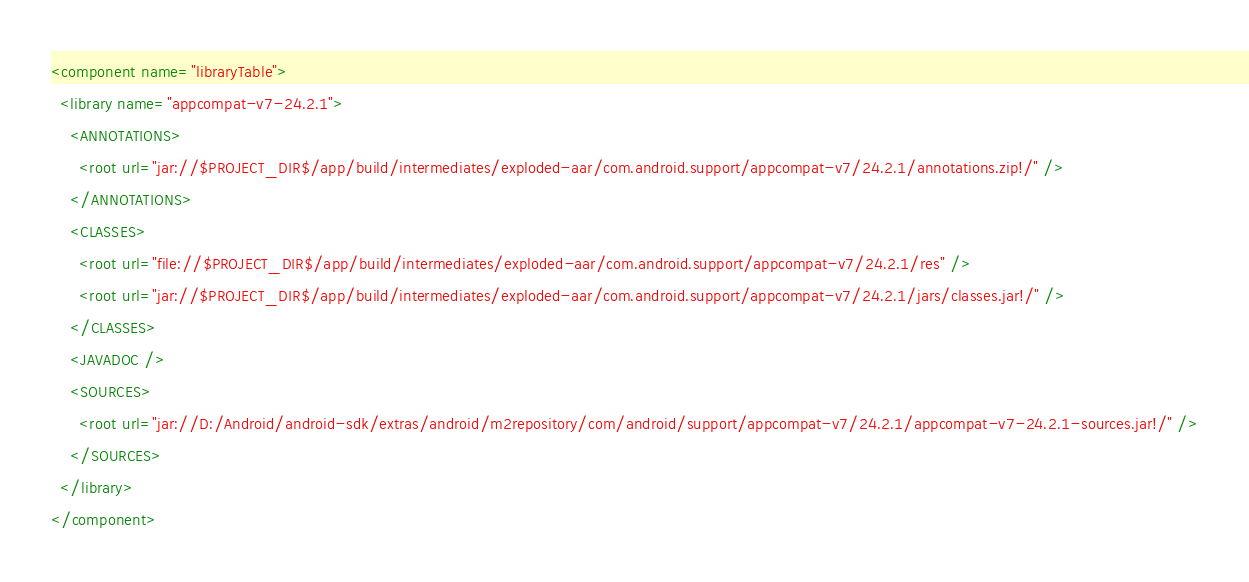Convert code to text. <code><loc_0><loc_0><loc_500><loc_500><_XML_><component name="libraryTable">
  <library name="appcompat-v7-24.2.1">
    <ANNOTATIONS>
      <root url="jar://$PROJECT_DIR$/app/build/intermediates/exploded-aar/com.android.support/appcompat-v7/24.2.1/annotations.zip!/" />
    </ANNOTATIONS>
    <CLASSES>
      <root url="file://$PROJECT_DIR$/app/build/intermediates/exploded-aar/com.android.support/appcompat-v7/24.2.1/res" />
      <root url="jar://$PROJECT_DIR$/app/build/intermediates/exploded-aar/com.android.support/appcompat-v7/24.2.1/jars/classes.jar!/" />
    </CLASSES>
    <JAVADOC />
    <SOURCES>
      <root url="jar://D:/Android/android-sdk/extras/android/m2repository/com/android/support/appcompat-v7/24.2.1/appcompat-v7-24.2.1-sources.jar!/" />
    </SOURCES>
  </library>
</component></code> 